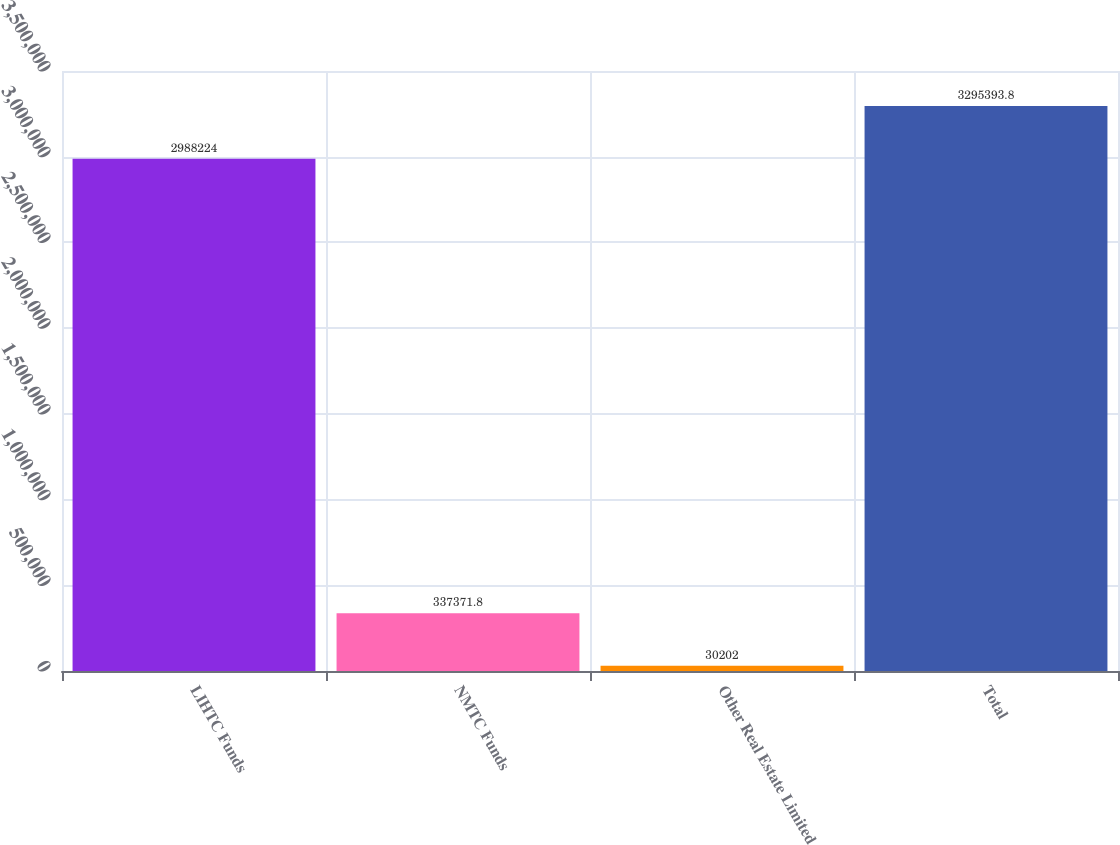<chart> <loc_0><loc_0><loc_500><loc_500><bar_chart><fcel>LIHTC Funds<fcel>NMTC Funds<fcel>Other Real Estate Limited<fcel>Total<nl><fcel>2.98822e+06<fcel>337372<fcel>30202<fcel>3.29539e+06<nl></chart> 